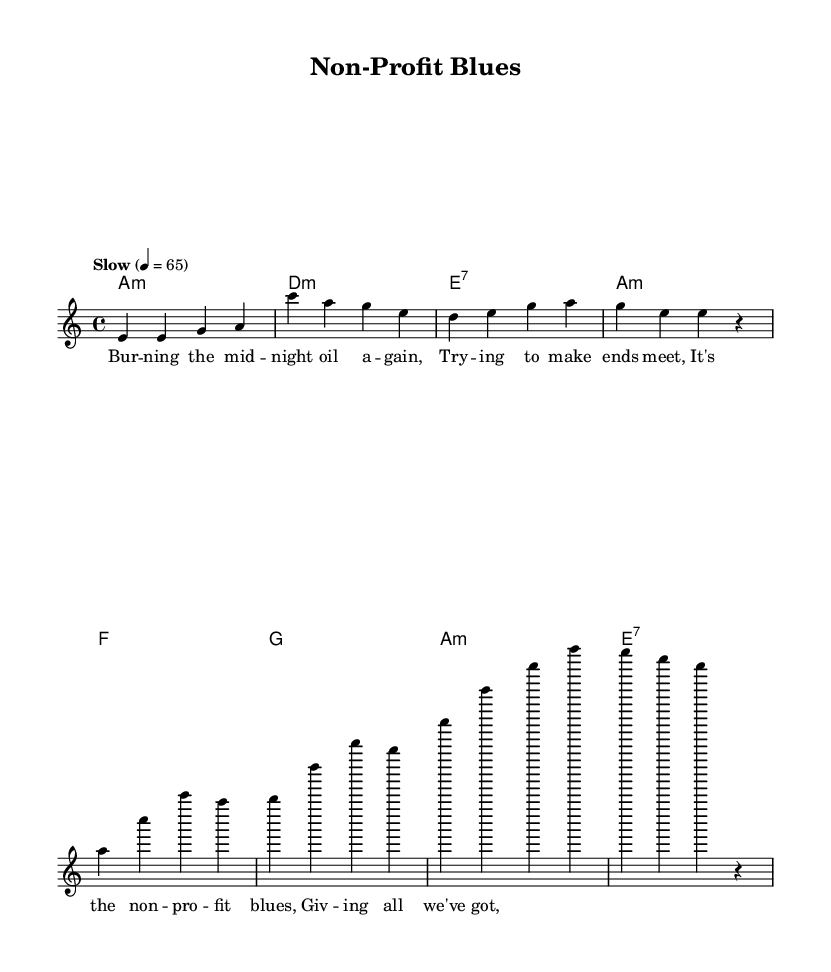What is the key signature of this music? The key signature shown is A minor, which is indicated by having no sharps or flats.
Answer: A minor What is the time signature of this music? The time signature is represented as 4/4, meaning there are four beats in each measure and a quarter note gets one beat.
Answer: 4/4 What is the tempo marking for this piece? The tempo marking stated is "Slow," with a metronome marking of 65 beats per minute, indicating a slow pace for the music.
Answer: Slow How many measures are in the verse? The verse section consists of four measures as seen in the notation provided before the chorus starts.
Answer: 4 What are the first and last chords of the chorus? The first chord is F major, and the last chord is E seventh, which are specified in the chord mode section of the score.
Answer: F, E7 What lyrical theme does the first verse reflect? The first verse reflects the theme of struggle and perseverance in managing the challenges faced by a non-profit, as indicated by the lyrics about working hard.
Answer: Working hard Why is the use of a minor key significant in this Electric Blues piece? The use of a minor key, particularly A minor, enhances the emotional depth and reflective quality typical of Electric Blues, conveying themes of sorrow and struggle through its melodic and harmonic choices.
Answer: Emotional depth 